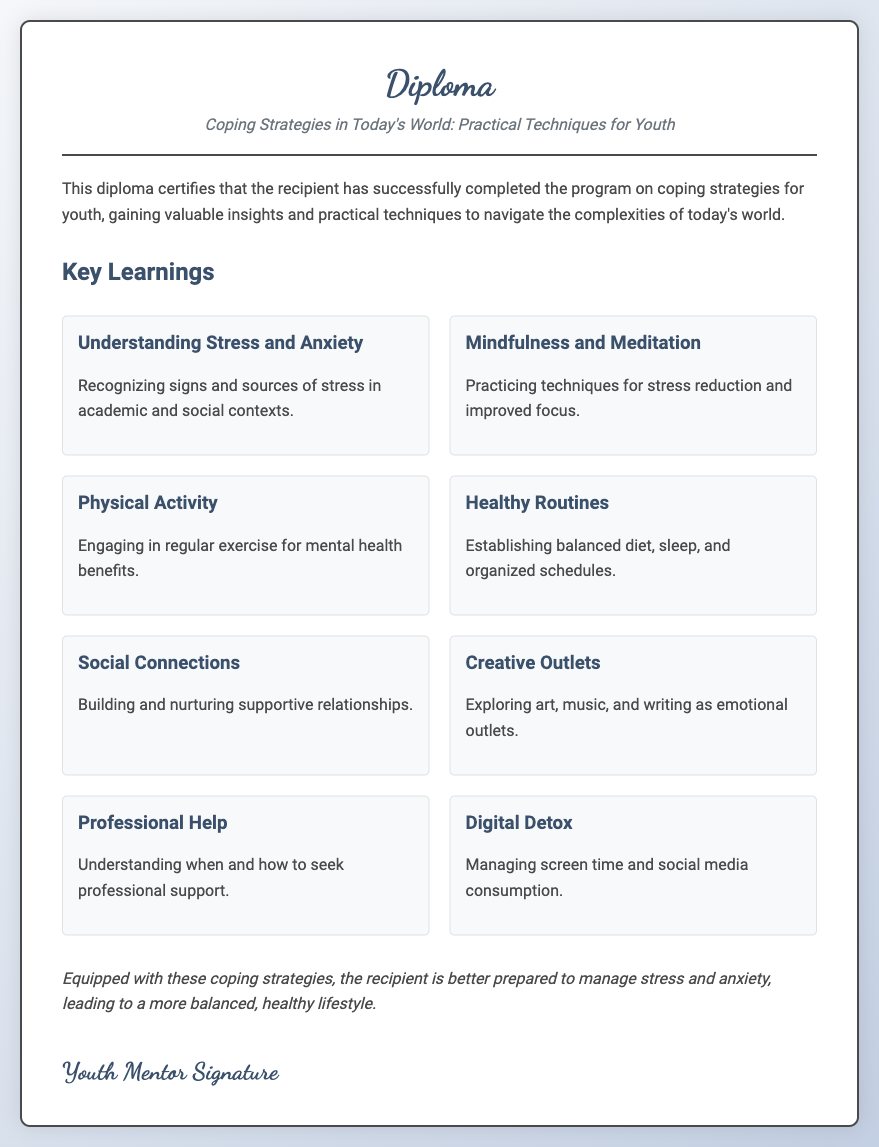What is the title of the diploma? The title can be found in the header section of the document, which specifies the subject of the diploma.
Answer: Coping Strategies in Today's World: Practical Techniques for Youth How many coping strategies are listed in the document? The number of coping strategies is indicated by the count of strategy sections presented under the Key Learnings heading.
Answer: Eight What is one method discussed for stress reduction? The document lists specific strategies, and one of them relates to mindfulness practices aimed at stress reduction.
Answer: Mindfulness and Meditation What is the main focus of the content described in the diploma? The content centers around various techniques that assist youth in managing stress and anxiety.
Answer: Coping strategies Which strategy emphasizes the importance of community? The strategies include building and nurturing relationships for support, which is crucial for mental well-being.
Answer: Social Connections What is the purpose of the diploma? The purpose of the diploma is stated in the introductory paragraph, which outlines the achievement recognized by the certificate.
Answer: To certify successful completion of the program on coping strategies for youth What technique is suggested for improved concentration? One of the strategies focuses on a specific practice aimed at enhancing focus by using mental techniques.
Answer: Mindfulness and Meditation What should youth do for emotional expression according to the diploma? The diploma suggests engaging in creative activities that allow for the expression of emotions effectively.
Answer: Creative Outlets 